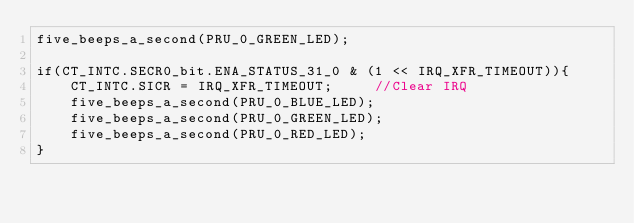<code> <loc_0><loc_0><loc_500><loc_500><_ObjectiveC_>five_beeps_a_second(PRU_0_GREEN_LED);

if(CT_INTC.SECR0_bit.ENA_STATUS_31_0 & (1 << IRQ_XFR_TIMEOUT)){
	CT_INTC.SICR = IRQ_XFR_TIMEOUT;		//Clear IRQ
	five_beeps_a_second(PRU_0_BLUE_LED);
	five_beeps_a_second(PRU_0_GREEN_LED);
	five_beeps_a_second(PRU_0_RED_LED);
}

</code> 